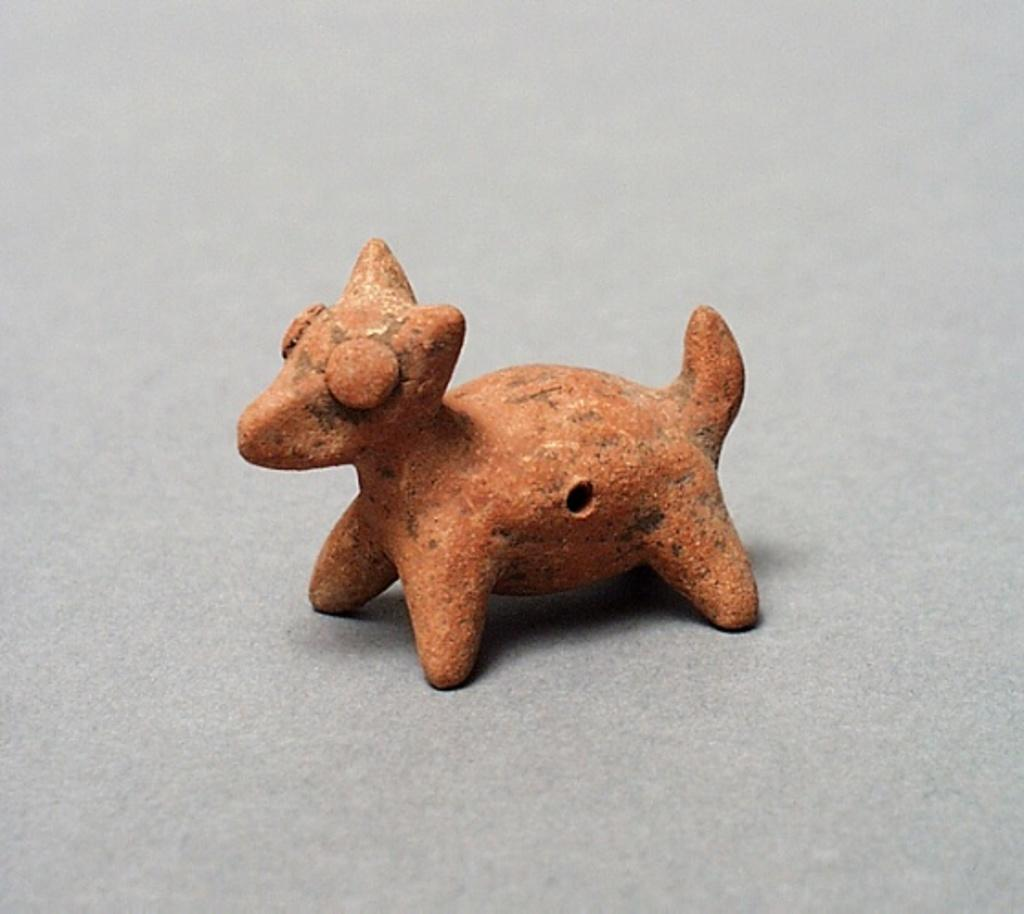What material is the doll in the image made of? The doll in the image is made up of stone. How many books are stacked next to the stone doll in the image? There are no books present in the image; it only features a stone doll. 